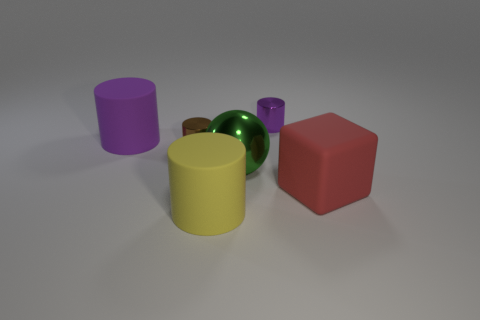There is a brown shiny object; is its size the same as the matte cylinder that is in front of the big purple thing?
Your response must be concise. No. Is the number of tiny things that are left of the big yellow rubber cylinder greater than the number of big purple blocks?
Provide a short and direct response. Yes. What number of cubes are the same size as the yellow cylinder?
Make the answer very short. 1. There is a purple thing behind the purple rubber thing; is it the same size as the shiny object that is to the left of the big ball?
Provide a short and direct response. Yes. Are there more large red objects that are in front of the purple metal thing than big yellow objects that are behind the big block?
Ensure brevity in your answer.  Yes. How many other tiny objects have the same shape as the small purple object?
Make the answer very short. 1. What is the material of the purple cylinder that is the same size as the green shiny ball?
Offer a very short reply. Rubber. Is there a brown object made of the same material as the big yellow cylinder?
Make the answer very short. No. Are there fewer purple metal cylinders in front of the tiny brown shiny thing than brown shiny objects?
Ensure brevity in your answer.  Yes. What is the purple thing to the left of the large matte cylinder that is in front of the shiny sphere made of?
Make the answer very short. Rubber. 